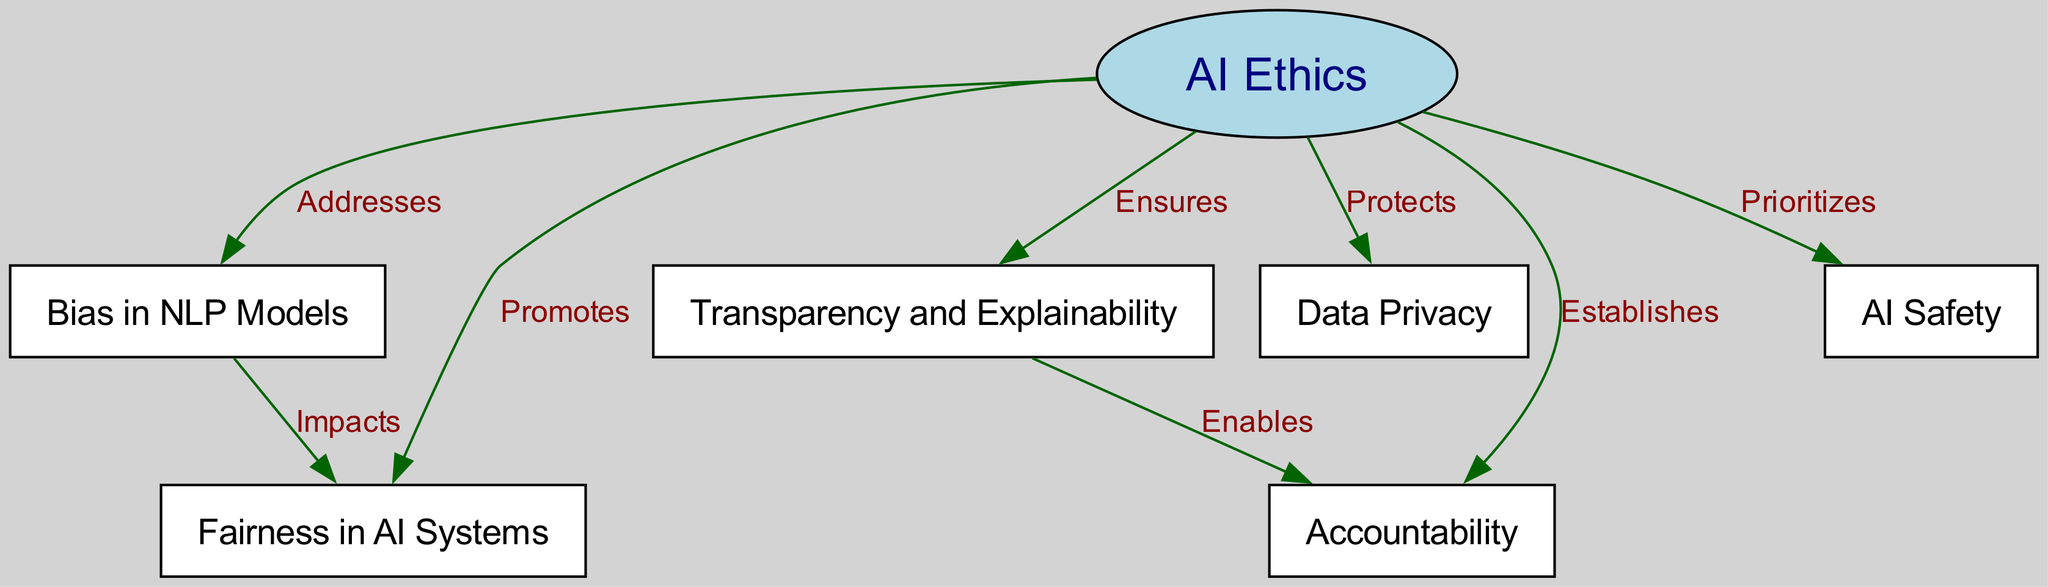What is the main topic of the diagram? The diagram's central node is labeled "AI Ethics," indicating that this is the main topic being addressed in the conceptual map.
Answer: AI Ethics How many nodes are present in the diagram? There are seven nodes identified in the diagram: AI Ethics, Bias in NLP Models, Fairness in AI Systems, Transparency and Explainability, Data Privacy, Accountability, and AI Safety. Counting these gives a total of seven nodes.
Answer: 7 What aspect does "AI Ethics" prioritize according to the diagram? The diagram indicates that "AI Ethics" prioritizes "AI Safety," as indicated by the directional edge from "AI Ethics" to "AI Safety" labeled "Prioritizes."
Answer: AI Safety Which node impacts fairness according to the diagram? The edge between "Bias in NLP Models" and "Fairness in AI Systems" shows that bias impacts fairness, as indicated by the label "Impacts" on their connecting edge.
Answer: Bias in NLP Models What relationship does "Transparency and Explainability" establish according to the diagram? The edge connecting "Transparency and Explainability" to "Accountability" is labeled "Enables," which indicates that transparency enables accountability in AI systems.
Answer: Enables What does "AI Ethics" protect according to the diagram? The edge from "AI Ethics" to "Data Privacy" is labeled "Protects," indicating that one of the ethical considerations is the protection of data privacy.
Answer: Data Privacy How does bias affect AI systems in the context of this diagram? Bias affects AI systems by impacting fairness, as depicted by the relationship shown in the edge between "Bias in NLP Models" and "Fairness in AI Systems."
Answer: Impacts What is the connection between transparency and accountability according to the diagram? The connection between "Transparency and Explainability" and "Accountability" shows that transparency enables accountability, illustrating the dependency of accountability on transparency within AI ethics.
Answer: Enables In the diagram, what does fairness relate to? Fairness relates to bias, as indicated by the directed edge from "Bias in NLP Models" to "Fairness in AI Systems," showing the influence of bias on fairness.
Answer: Bias in NLP Models 